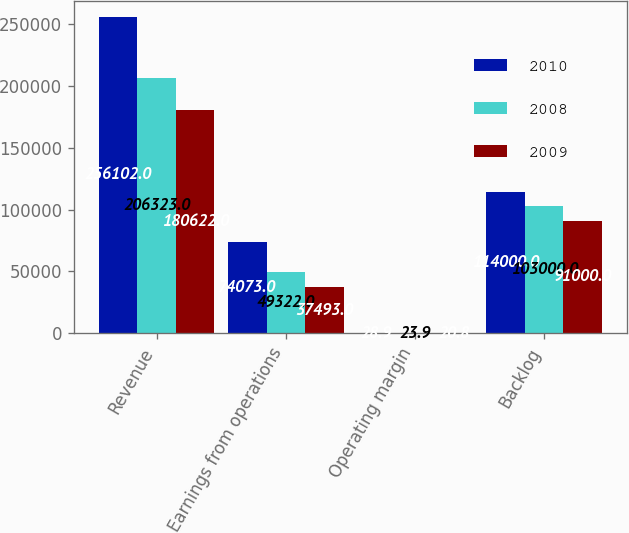Convert chart to OTSL. <chart><loc_0><loc_0><loc_500><loc_500><stacked_bar_chart><ecel><fcel>Revenue<fcel>Earnings from operations<fcel>Operating margin<fcel>Backlog<nl><fcel>2010<fcel>256102<fcel>74073<fcel>28.9<fcel>114000<nl><fcel>2008<fcel>206323<fcel>49322<fcel>23.9<fcel>103000<nl><fcel>2009<fcel>180622<fcel>37493<fcel>20.8<fcel>91000<nl></chart> 